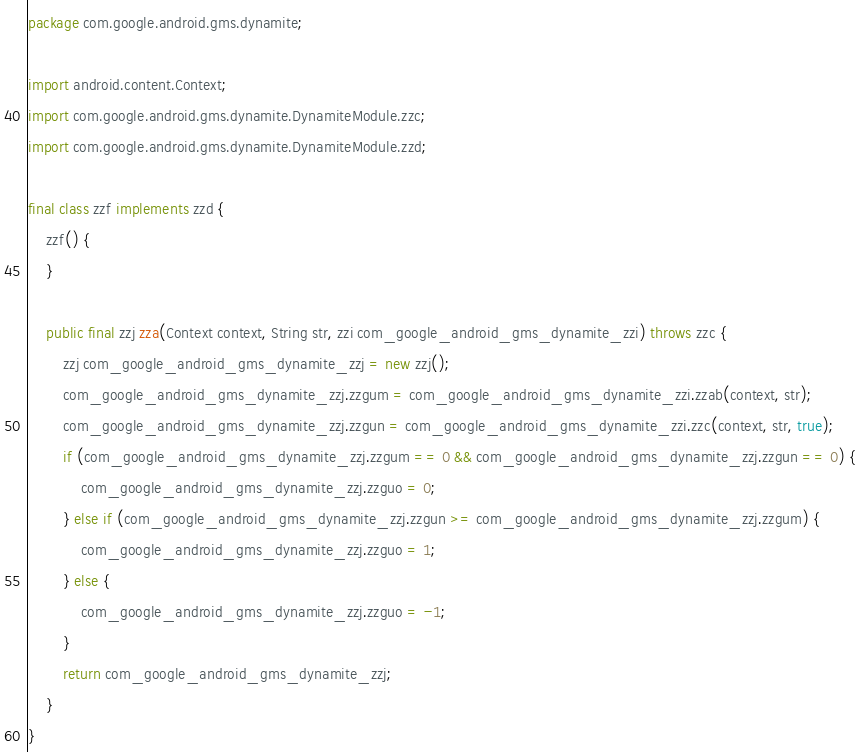<code> <loc_0><loc_0><loc_500><loc_500><_Java_>package com.google.android.gms.dynamite;

import android.content.Context;
import com.google.android.gms.dynamite.DynamiteModule.zzc;
import com.google.android.gms.dynamite.DynamiteModule.zzd;

final class zzf implements zzd {
    zzf() {
    }

    public final zzj zza(Context context, String str, zzi com_google_android_gms_dynamite_zzi) throws zzc {
        zzj com_google_android_gms_dynamite_zzj = new zzj();
        com_google_android_gms_dynamite_zzj.zzgum = com_google_android_gms_dynamite_zzi.zzab(context, str);
        com_google_android_gms_dynamite_zzj.zzgun = com_google_android_gms_dynamite_zzi.zzc(context, str, true);
        if (com_google_android_gms_dynamite_zzj.zzgum == 0 && com_google_android_gms_dynamite_zzj.zzgun == 0) {
            com_google_android_gms_dynamite_zzj.zzguo = 0;
        } else if (com_google_android_gms_dynamite_zzj.zzgun >= com_google_android_gms_dynamite_zzj.zzgum) {
            com_google_android_gms_dynamite_zzj.zzguo = 1;
        } else {
            com_google_android_gms_dynamite_zzj.zzguo = -1;
        }
        return com_google_android_gms_dynamite_zzj;
    }
}
</code> 